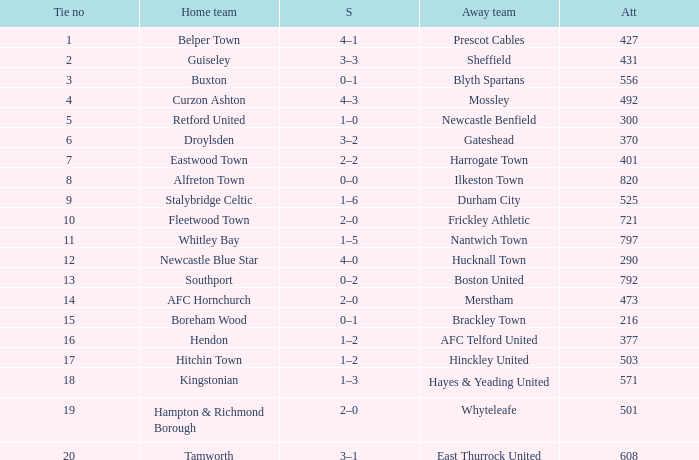What was the score for home team AFC Hornchurch? 2–0. 